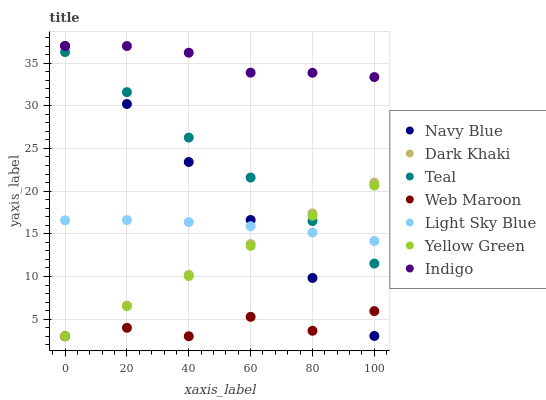Does Web Maroon have the minimum area under the curve?
Answer yes or no. Yes. Does Indigo have the maximum area under the curve?
Answer yes or no. Yes. Does Yellow Green have the minimum area under the curve?
Answer yes or no. No. Does Yellow Green have the maximum area under the curve?
Answer yes or no. No. Is Dark Khaki the smoothest?
Answer yes or no. Yes. Is Web Maroon the roughest?
Answer yes or no. Yes. Is Yellow Green the smoothest?
Answer yes or no. No. Is Yellow Green the roughest?
Answer yes or no. No. Does Yellow Green have the lowest value?
Answer yes or no. Yes. Does Navy Blue have the lowest value?
Answer yes or no. No. Does Navy Blue have the highest value?
Answer yes or no. Yes. Does Yellow Green have the highest value?
Answer yes or no. No. Is Teal less than Indigo?
Answer yes or no. Yes. Is Indigo greater than Yellow Green?
Answer yes or no. Yes. Does Indigo intersect Navy Blue?
Answer yes or no. Yes. Is Indigo less than Navy Blue?
Answer yes or no. No. Is Indigo greater than Navy Blue?
Answer yes or no. No. Does Teal intersect Indigo?
Answer yes or no. No. 